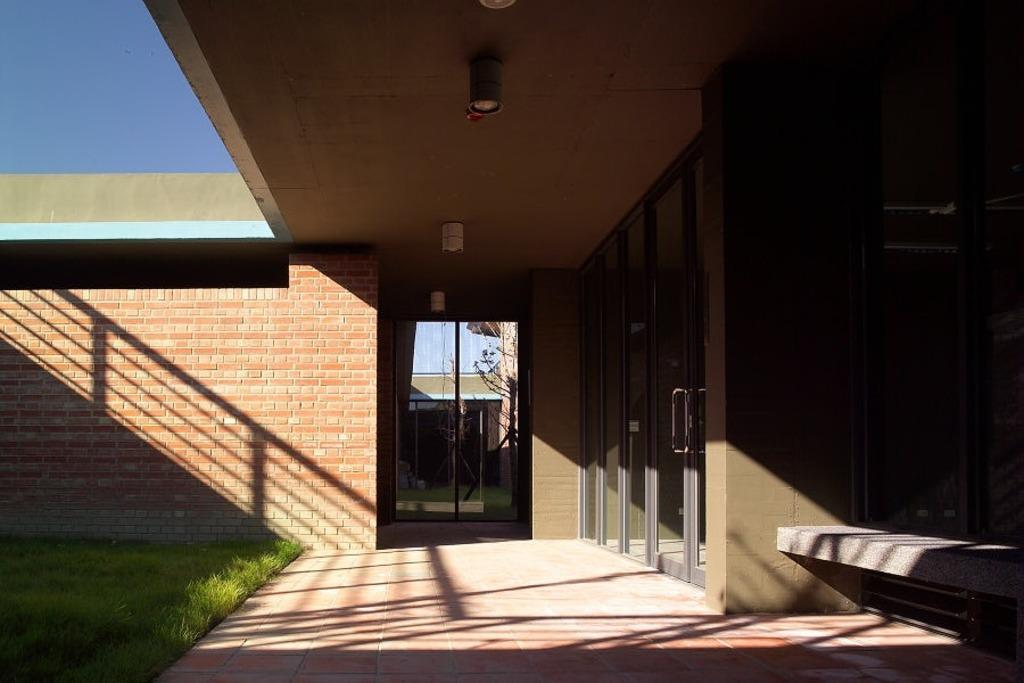What type of structure is visible in the image? There is a house in the image. What type of doors can be seen on the house? There are glass doors in the image. What material is used for the wall on the house? There is a brick wall in the image. What type of vegetation is on the left side of the image? There is grass on the left side of the image. What is visible at the top of the image? The sky is clear and visible at the top of the image. How many cacti are visible in the yard in the image? There are no cacti visible in the image, as the vegetation on the left side of the image is grass. What type of step can be seen leading up to the house in the image? There are no steps visible leading up to the house in the image. 